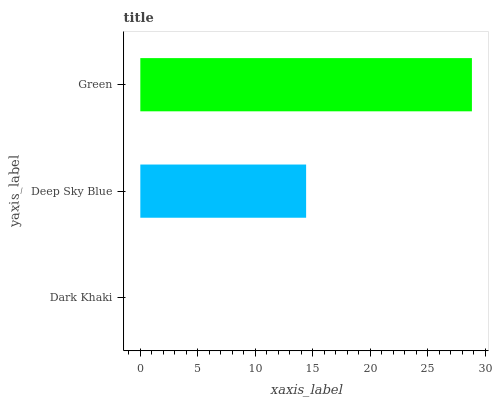Is Dark Khaki the minimum?
Answer yes or no. Yes. Is Green the maximum?
Answer yes or no. Yes. Is Deep Sky Blue the minimum?
Answer yes or no. No. Is Deep Sky Blue the maximum?
Answer yes or no. No. Is Deep Sky Blue greater than Dark Khaki?
Answer yes or no. Yes. Is Dark Khaki less than Deep Sky Blue?
Answer yes or no. Yes. Is Dark Khaki greater than Deep Sky Blue?
Answer yes or no. No. Is Deep Sky Blue less than Dark Khaki?
Answer yes or no. No. Is Deep Sky Blue the high median?
Answer yes or no. Yes. Is Deep Sky Blue the low median?
Answer yes or no. Yes. Is Dark Khaki the high median?
Answer yes or no. No. Is Green the low median?
Answer yes or no. No. 